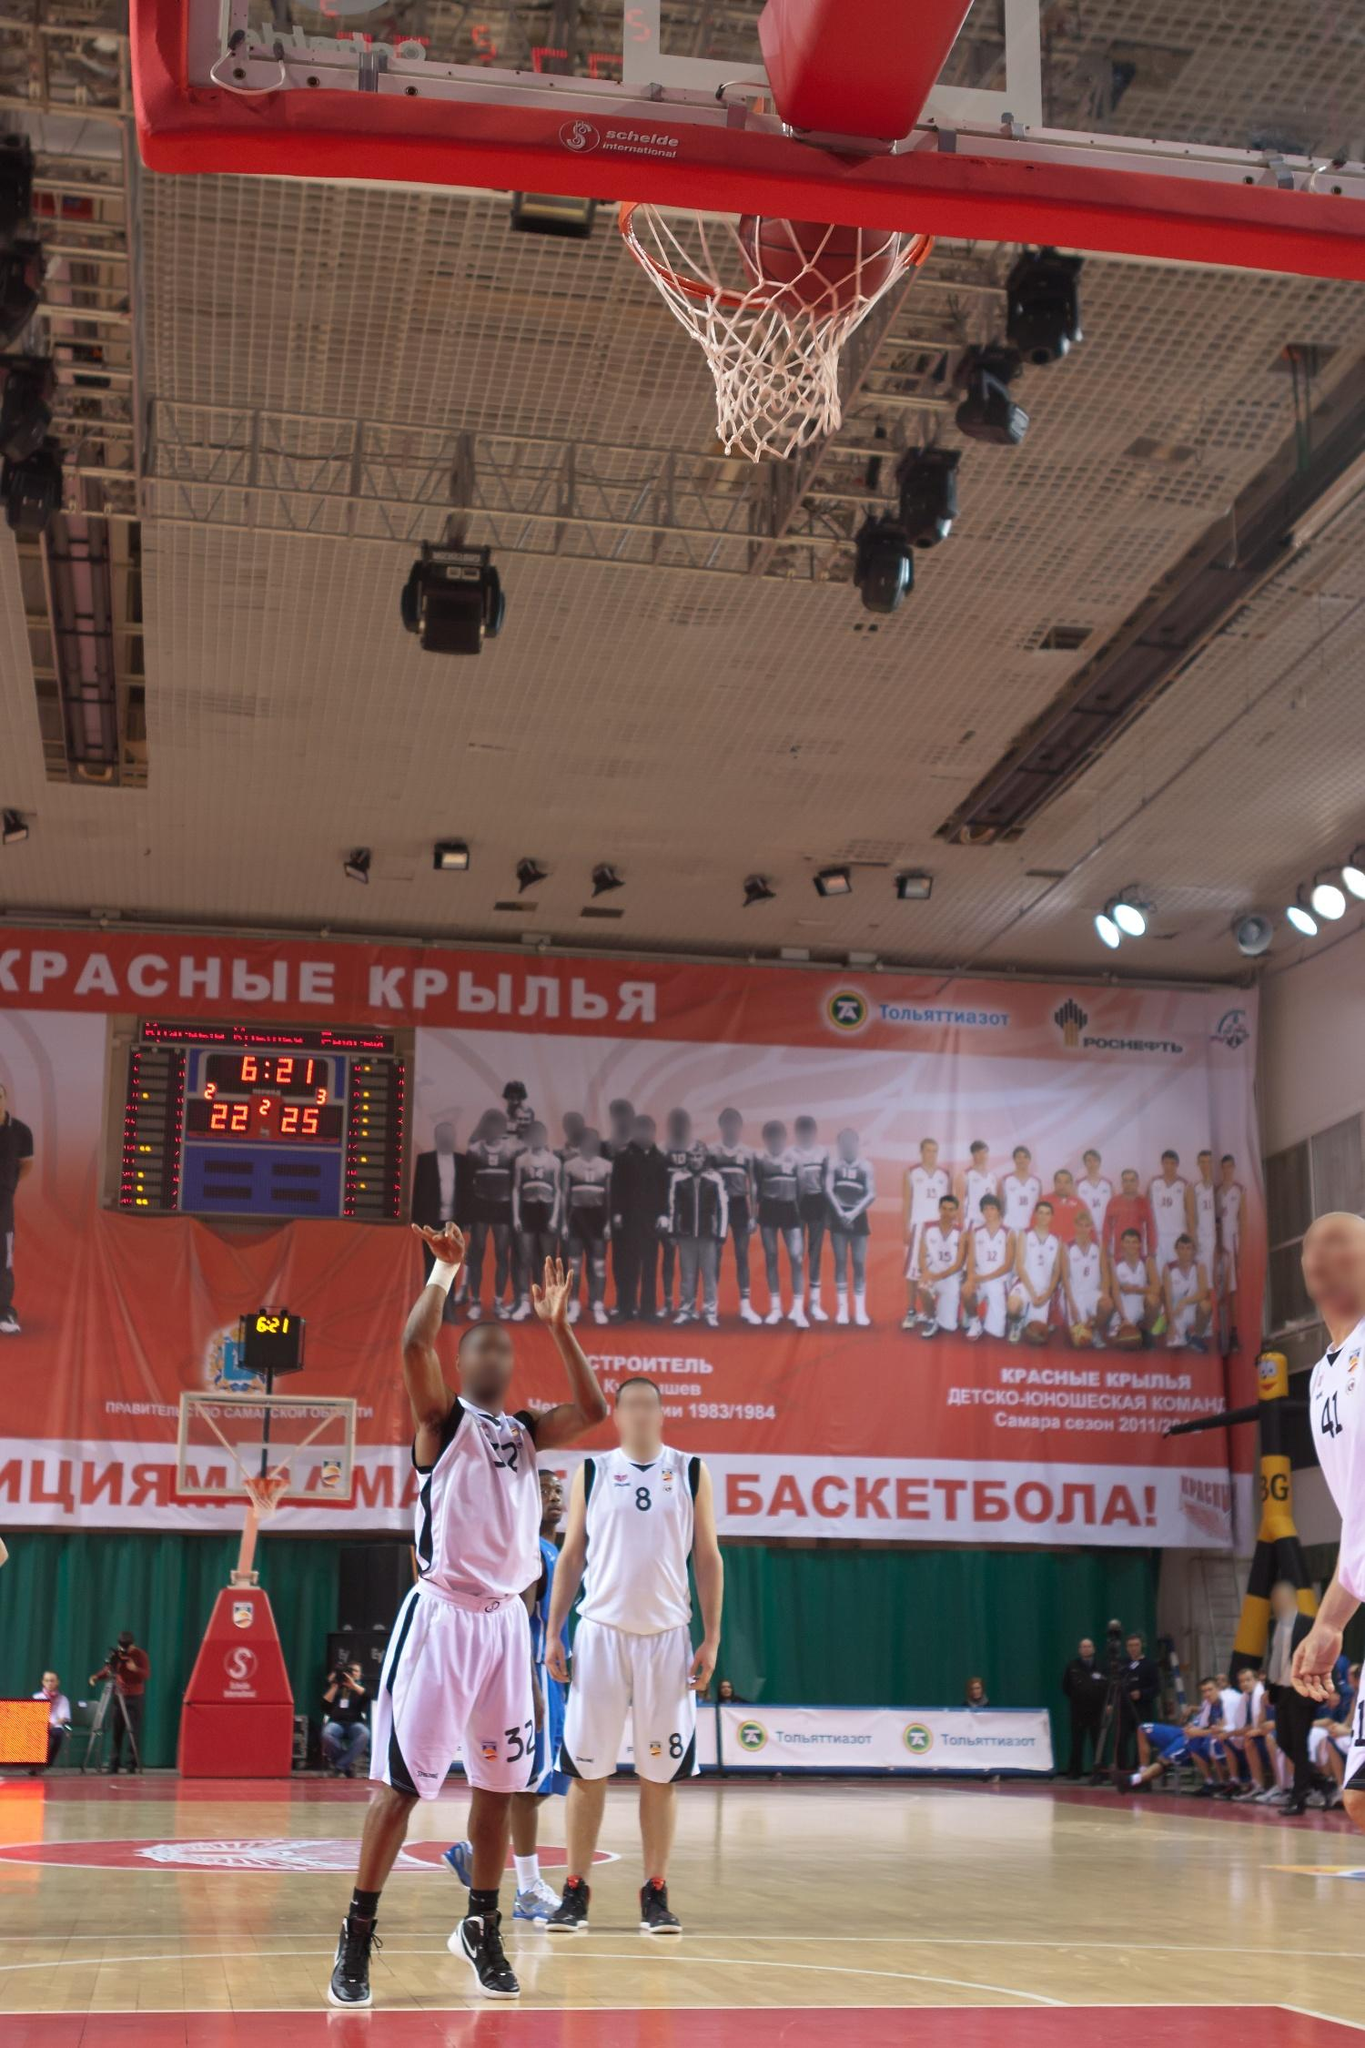Can you create a narrative around this game's pivotal moment? In the heated second quarter of a tightly contested basketball match, the air buzzes with tension. The Red Wings, draped in their signature white jerseys, are trailing closely behind. The scoreboard flickers with the numbers 22-25, leaving no room for complacency. With only 6 minutes and 21 seconds remaining, every second pulsates with significance.

Suddenly, #32 of the Red Wings seizes the moment. Eyes locked onto the basket, he springs into the air, muscles rippling with the effort. The crowd collectively holds its breath, the silence almost tangible. Opposing him is #41 of the Blue Team, his face a mask of concentration, extending every inch of his frame to deflect the shot.

Time seems to slow as the ball arcs gracefully toward the hoop. Spectators, players, and coaches alike are frozen in anticipation. The intensity of the moment is mirrored on the court, with teammates frantically positioning themselves to either rebound or defend, their eyes darting between the ball and players.

Then, in a split second, the ball reaches its zenith and begins its descent, a metaphorical climax in this furious battle. The outcome of this shot could tilt the scales, shaping the narrative of the game and possibly the season. Will #32’s shot bridge the gap, or will #41’s towering defense maintain their slim lead? The next heartbeat will tell. Imagine the player's thoughts as he makes that jump for the shot. As I leap off the ground, everything else fades away—the roar of the crowd, the squeak of sneakers on the hardwood, even the clock's relentless countdown. All I hear now is the thump of my own heart, pounding out a rapid beat that matches the rhythm of this pivotal play. My focus narrows to the orange rim of the basket, a solitary target suspended in a sea of chaos.

'Just breathe,' I remind myself, a mantra drilled into us through endless hours of practice. My fingers tighten around the slick leather of the ball, feeling every groove and seam. 'Visualize. Execute.' I've done this a thousand times, but this—this is different. This is not just any game; it's the game that could define our season.

I sense rather than see #41 of the Blue Team as he lunges upward, arms reaching for the sky to block my shot. The shadow of his presence looms large, but my muscle memory takes over. My wrist snaps forward, releasing the ball in a perfect arc. It's out of my hands now, suspended in the air—a tangible representation of all our efforts.

Time stretches, the world hangs in the balance. 'Will it make it?' The question echoes in my mind, yet there's a strange clarity and calm that follows. I reassert my landing, eyes still locked on the ball as it begins its descent. The outcome is unknown, but in this frozen moment, I'm at peace with whatever happens next. All that matters is that I've given my all.  How about a creative twist? What if the game had an unexpected interruption? Just as Player #32 releases the ball, an unexpected twist unfurls. The gym lights flicker, and suddenly, the roar of a mighty dragon echoes through the arena. Spectators gasp and point skyward as the roof begins to split open dramatically—not by some mechanical failure, but by the majestic wings of an enormous, mythical dragon descending into the court.

Players freeze, the basketball forgotten and mid-air, as the dragon’s iridescent scales shimmer in the artificial light. Its eyes, glowing with ancient wisdom, scan the bewildered crowd before focusing back on the game. With a mighty flap of its wings, it swoops down, gently catches the ball in its talons, and hovers above the players. Everyone stares in stunned silence, trying to make sense of this otherworldly intervention.

In a surprising turn, the dragon carefully places the ball into the hoop, scoring an effortless basket for the Red Wings. It then arches its neck, releasing a deep, rumbling roar as if to cheer the team on. The scoreboard buzzes, and the points for the Red Wings flicker upward, now leading the game.

With a final, regal look around, the dragon beats its wings again, ascending back through the roof, leaving a trail of sparkles in its wake. The gym’s lights stabilize, and after a moment that feels like eternity, the crowd erupts into unprecedented cheers and applause. Was it magic? A shared hallucination? No one knew, but for this day, this game, the Red Wings had a legendary ally.  Let’s ground it back to reality. Describe a scenario where a player's remarkable sportsmanship becomes the highlight of the game. In the final minutes of the second quarter, with the score standing precariously at 22-25, a sudden hush fell over the crowd. Player #32 from the Red Wings had just made an incredible leap, aiming to narrow the gap with a crucial shot. However, midair, he collided accidentally with Player #41 from the opposing team. Both fell hard to the court, the ball rolling away aimlessly.

As the referee’s whistle pierced the tense atmosphere, Player #32 immediately rose to his feet—not to protest or demand a foul, but to extend a hand to #41. With a sportsmanlike gesture, he helped #41 up, patting him on the back and checking if he was alright.

The moment resonated with the audience and players alike. The jumbotron captured the scene, replaying it as the announcer highlighted the act of respect and camaraderie amid fierce competition. Both players nodded to each other, a silent acknowledgment of mutual respect and understanding that transcended the game.

The spectators, momentarily moved by the display of sportsmanship, erupted in cheers and applause. This gesture of respect not only uplifted the team spirit but also set an example for the young fans watching the game. The scoreboard may have shown a numeric battle, but in that instant, it was clear that the true victory lay in the honorable conduct displayed on the court. The game continued, imbued with a renewed sense of sportsmanship and respect.  Imagine a brief, realistic dialogue between the two players after the game. Player #32: "Hey man, good game out there. That was a tough battle."

Player #41: "Thanks. You too. That jump shot you made was impressive; almost had me there."

Player #32: "Appreciate it. And hey, I'm sorry about that collision. Glad you're okay."

Player #41: "No worries, it’s part of the game. I respect how you handled it."

Player #32: "sharegpt4v/same here. Good luck with the rest of your season."

Player #41: "Thanks, you too. Maybe we’ll face off again in the finals."

Player #32: "Looking forward to it. Take care." 